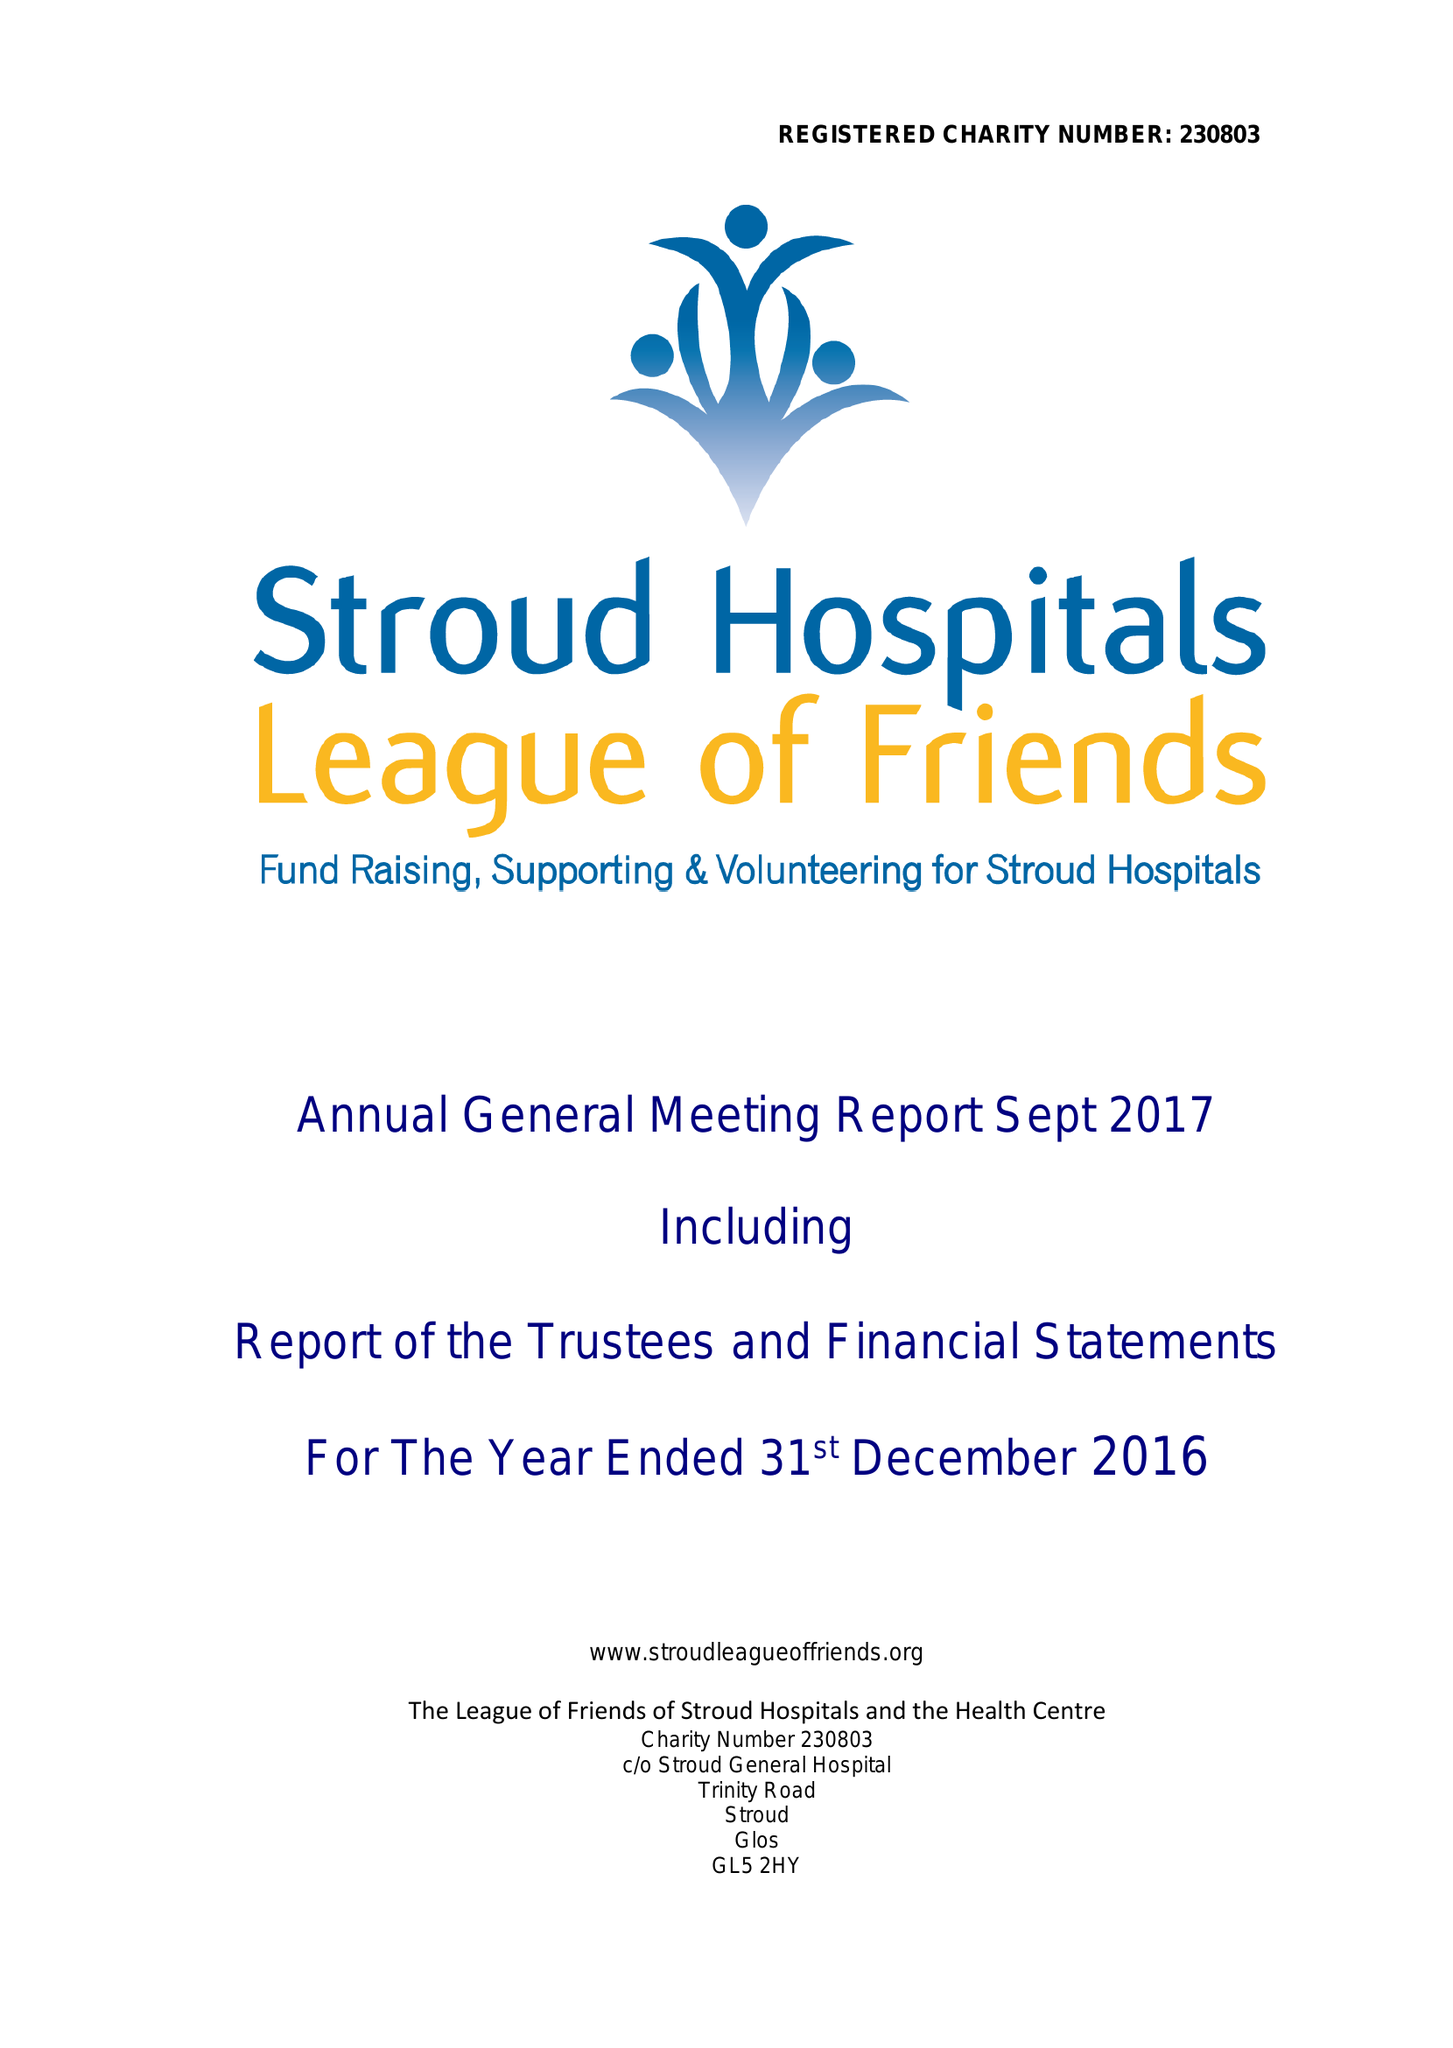What is the value for the report_date?
Answer the question using a single word or phrase. 2016-12-31 